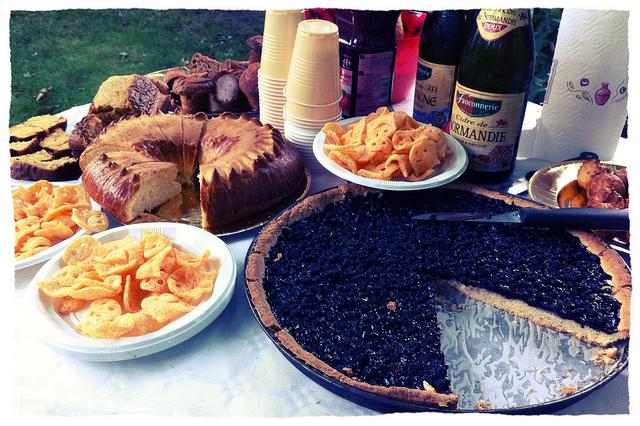Are all of the foods pictured desserts?
Give a very brief answer. Yes. Has the pie been sliced or not sliced?
Give a very brief answer. Sliced. What material are the cups made of?
Quick response, please. Plastic. 